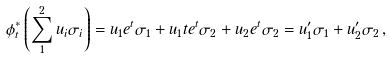Convert formula to latex. <formula><loc_0><loc_0><loc_500><loc_500>\phi _ { t } ^ { * } \left ( \sum _ { 1 } ^ { 2 } u _ { i } \sigma _ { i } \right ) = u _ { 1 } e ^ { t } \sigma _ { 1 } + u _ { 1 } t e ^ { t } \sigma _ { 2 } + u _ { 2 } e ^ { t } \sigma _ { 2 } = u _ { 1 } ^ { \prime } \sigma _ { 1 } + u _ { 2 } ^ { \prime } \sigma _ { 2 } \, ,</formula> 